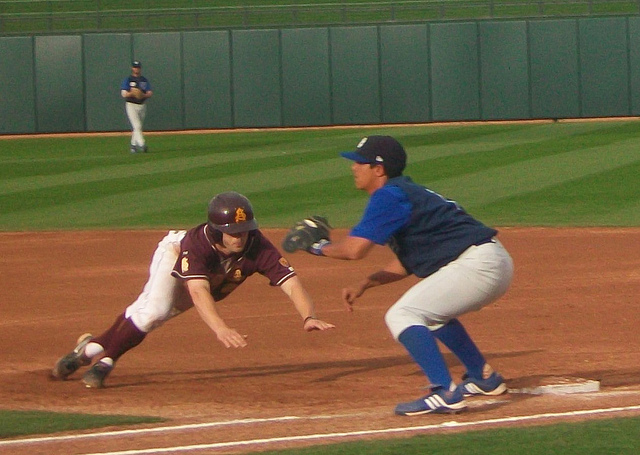<image>Who has the ball? I don't know who has the ball. It could be the baseman, the pitcher, or no one. Who has the ball? I don't know who has the ball. It can be seen that 'baseman', 'first baseman', 'pitcher', 'catcher' or 'no one' has the ball. 